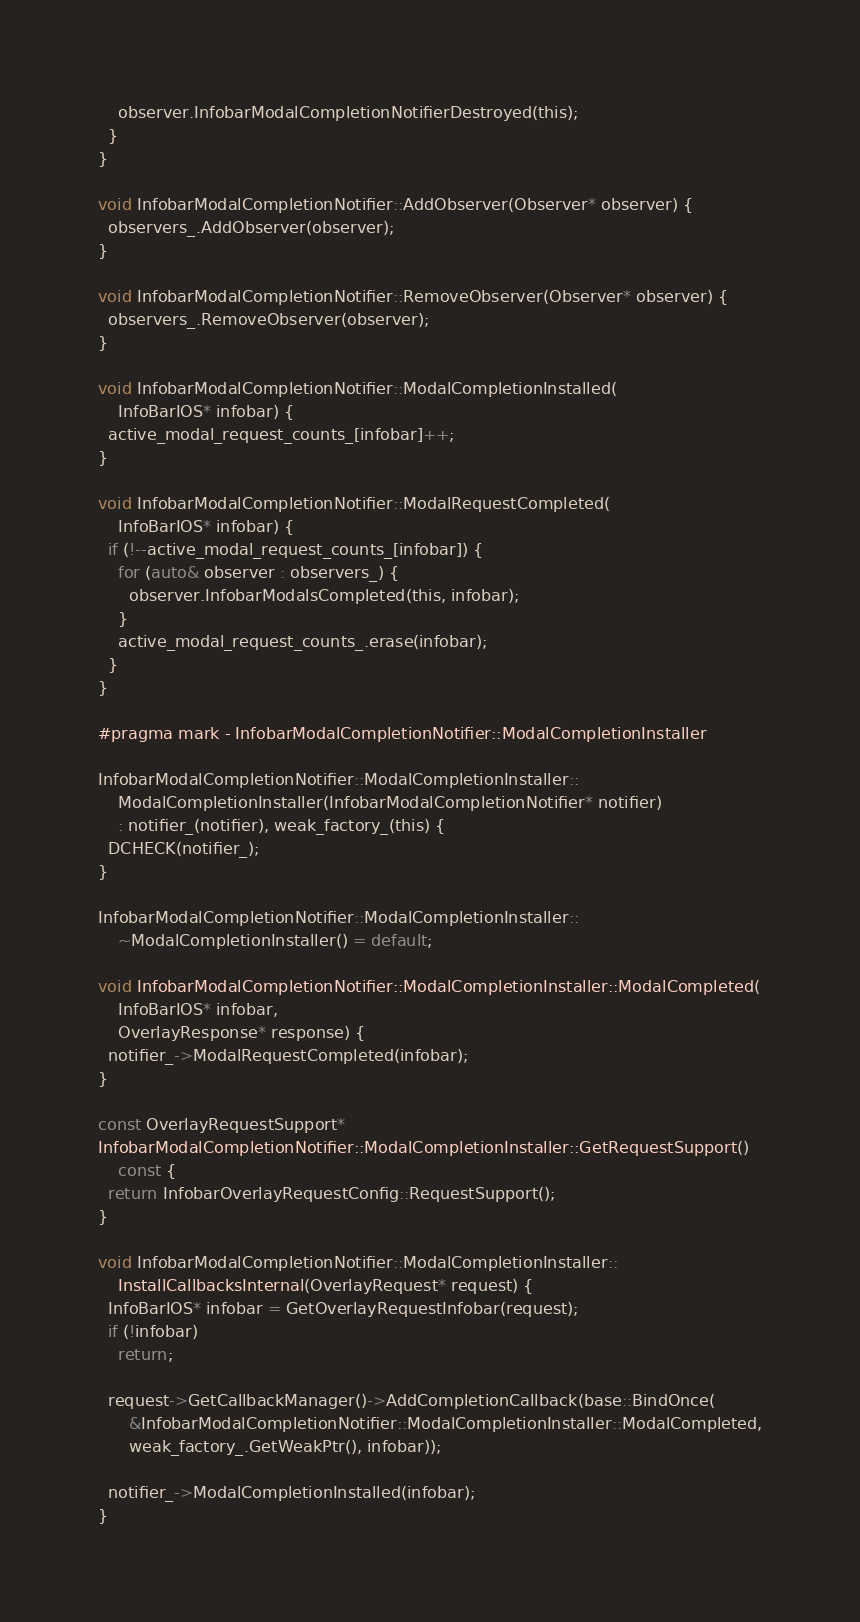<code> <loc_0><loc_0><loc_500><loc_500><_ObjectiveC_>    observer.InfobarModalCompletionNotifierDestroyed(this);
  }
}

void InfobarModalCompletionNotifier::AddObserver(Observer* observer) {
  observers_.AddObserver(observer);
}

void InfobarModalCompletionNotifier::RemoveObserver(Observer* observer) {
  observers_.RemoveObserver(observer);
}

void InfobarModalCompletionNotifier::ModalCompletionInstalled(
    InfoBarIOS* infobar) {
  active_modal_request_counts_[infobar]++;
}

void InfobarModalCompletionNotifier::ModalRequestCompleted(
    InfoBarIOS* infobar) {
  if (!--active_modal_request_counts_[infobar]) {
    for (auto& observer : observers_) {
      observer.InfobarModalsCompleted(this, infobar);
    }
    active_modal_request_counts_.erase(infobar);
  }
}

#pragma mark - InfobarModalCompletionNotifier::ModalCompletionInstaller

InfobarModalCompletionNotifier::ModalCompletionInstaller::
    ModalCompletionInstaller(InfobarModalCompletionNotifier* notifier)
    : notifier_(notifier), weak_factory_(this) {
  DCHECK(notifier_);
}

InfobarModalCompletionNotifier::ModalCompletionInstaller::
    ~ModalCompletionInstaller() = default;

void InfobarModalCompletionNotifier::ModalCompletionInstaller::ModalCompleted(
    InfoBarIOS* infobar,
    OverlayResponse* response) {
  notifier_->ModalRequestCompleted(infobar);
}

const OverlayRequestSupport*
InfobarModalCompletionNotifier::ModalCompletionInstaller::GetRequestSupport()
    const {
  return InfobarOverlayRequestConfig::RequestSupport();
}

void InfobarModalCompletionNotifier::ModalCompletionInstaller::
    InstallCallbacksInternal(OverlayRequest* request) {
  InfoBarIOS* infobar = GetOverlayRequestInfobar(request);
  if (!infobar)
    return;

  request->GetCallbackManager()->AddCompletionCallback(base::BindOnce(
      &InfobarModalCompletionNotifier::ModalCompletionInstaller::ModalCompleted,
      weak_factory_.GetWeakPtr(), infobar));

  notifier_->ModalCompletionInstalled(infobar);
}
</code> 